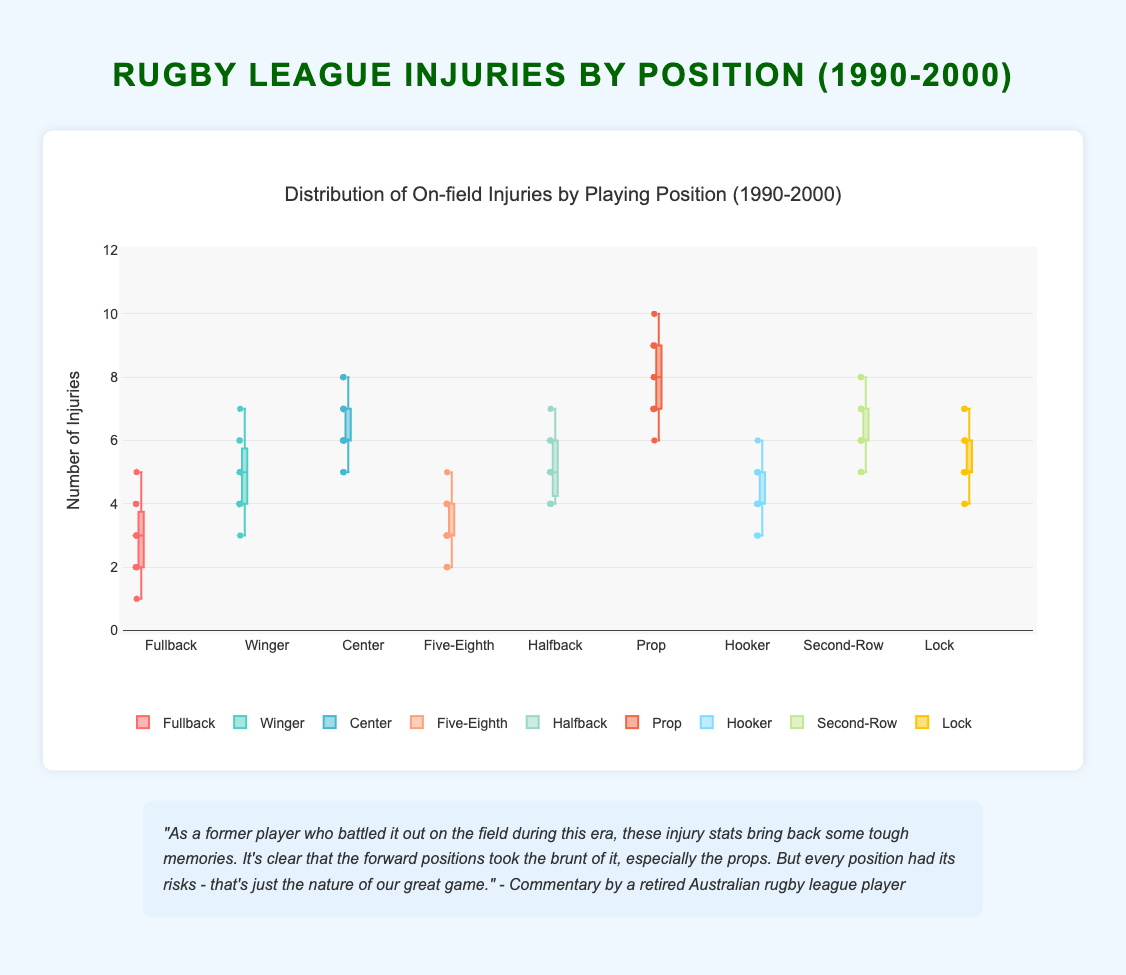1. What is the title of the figure? The title of the figure is displayed prominently at the top.
Answer: Distribution of On-field Injuries by Playing Position (1990-2000) 2. Which playing position has the highest median number of injuries? By examining the central line within each box, which represents the median, we can identify the position with the highest median number of injuries.
Answer: Prop 3. How many playing positions are included in the figure? Each distinct box in the box plot represents a playing position. Counting these will give us the total number of positions included.
Answer: 9 4. What is the range of injuries for the position of Five-Eighth? The range can be determined by looking at the minimum and maximum points (bottom and top whiskers) for the Five-Eighth position.
Answer: 2 to 5 5. Which positions have outliers? Outliers are generally marked as individual points that lie outside the whiskers of the box plot. Identifying these points will show which positions have outliers.
Answer: Fullback, Hooker 6. Compare the median number of injuries for the Fullback and Winger positions. Which is higher? Locate the median lines inside the boxes for both Fullback and Winger positions and compare their values.
Answer: Winger 7. What is the interquartile range (IQR) for the Prop position? IQR is the difference between the third quartile (Q3) and the first quartile (Q1). For the Prop position, identify the top and bottom of the box and subtract the lower quartile value from the upper quartile value.
Answer: 2 8. Which position has the most consistent injury numbers over the ten-year period? The most consistent position will have the narrowest box and shortest whiskers, indicating a lower spread of data.
Answer: Hooker 9. For the Winger position, during which years do we observe the maximum and minimum injury numbers? By looking at the individual points plotted inside the Winger box, identify the highest and lowest values and map them to the corresponding years.
Answer: Maximum: 1996, Minimum: 1992 10. How does the spread of injury numbers for the Halfback compare to the Lock position? Compare the length of the boxes and whiskers of the Halfback and Lock positions to evaluate the spread of injury numbers.
Answer: Similar spread 